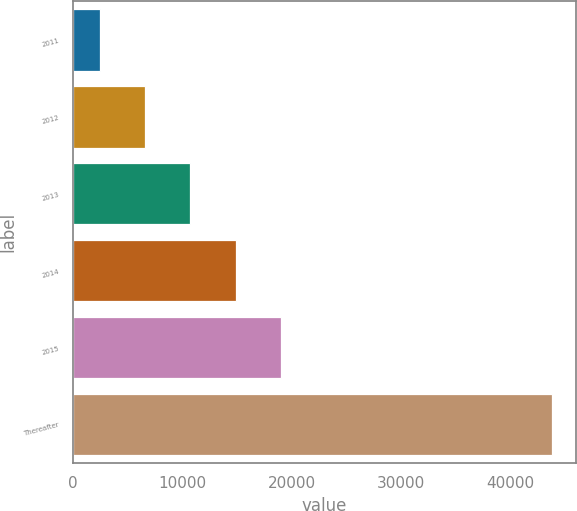<chart> <loc_0><loc_0><loc_500><loc_500><bar_chart><fcel>2011<fcel>2012<fcel>2013<fcel>2014<fcel>2015<fcel>Thereafter<nl><fcel>2468<fcel>6599.5<fcel>10731<fcel>14862.5<fcel>18994<fcel>43783<nl></chart> 